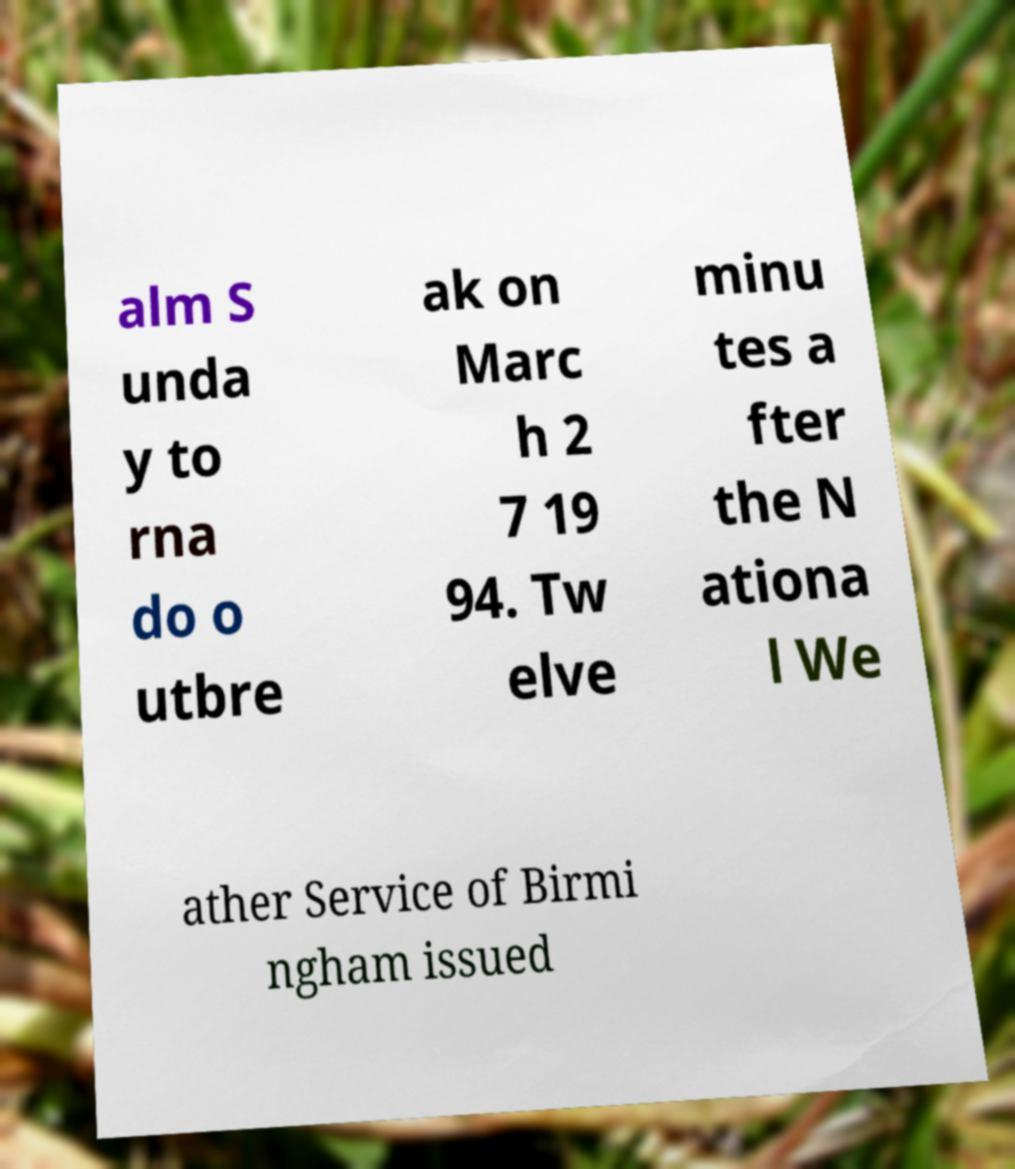Please read and relay the text visible in this image. What does it say? alm S unda y to rna do o utbre ak on Marc h 2 7 19 94. Tw elve minu tes a fter the N ationa l We ather Service of Birmi ngham issued 